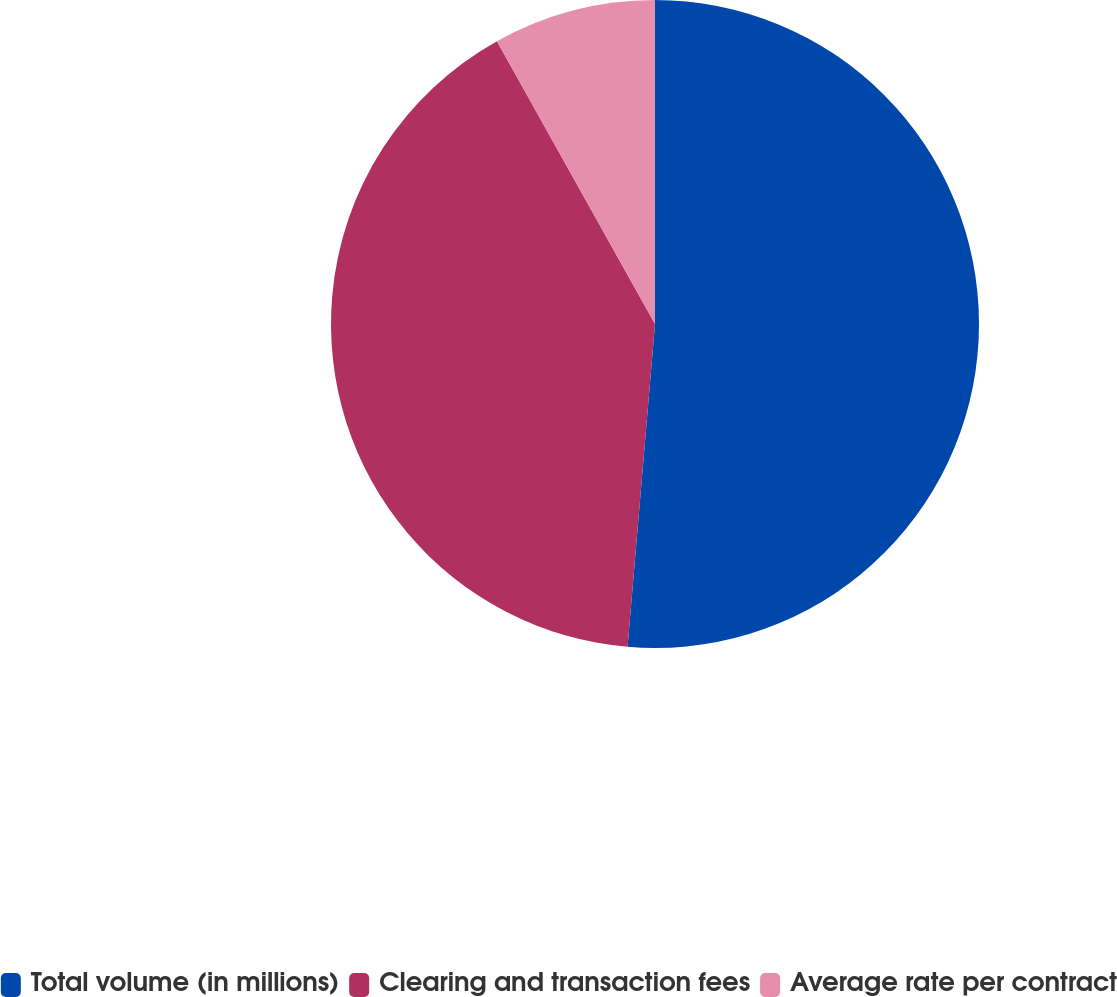Convert chart to OTSL. <chart><loc_0><loc_0><loc_500><loc_500><pie_chart><fcel>Total volume (in millions)<fcel>Clearing and transaction fees<fcel>Average rate per contract<nl><fcel>51.35%<fcel>40.54%<fcel>8.11%<nl></chart> 